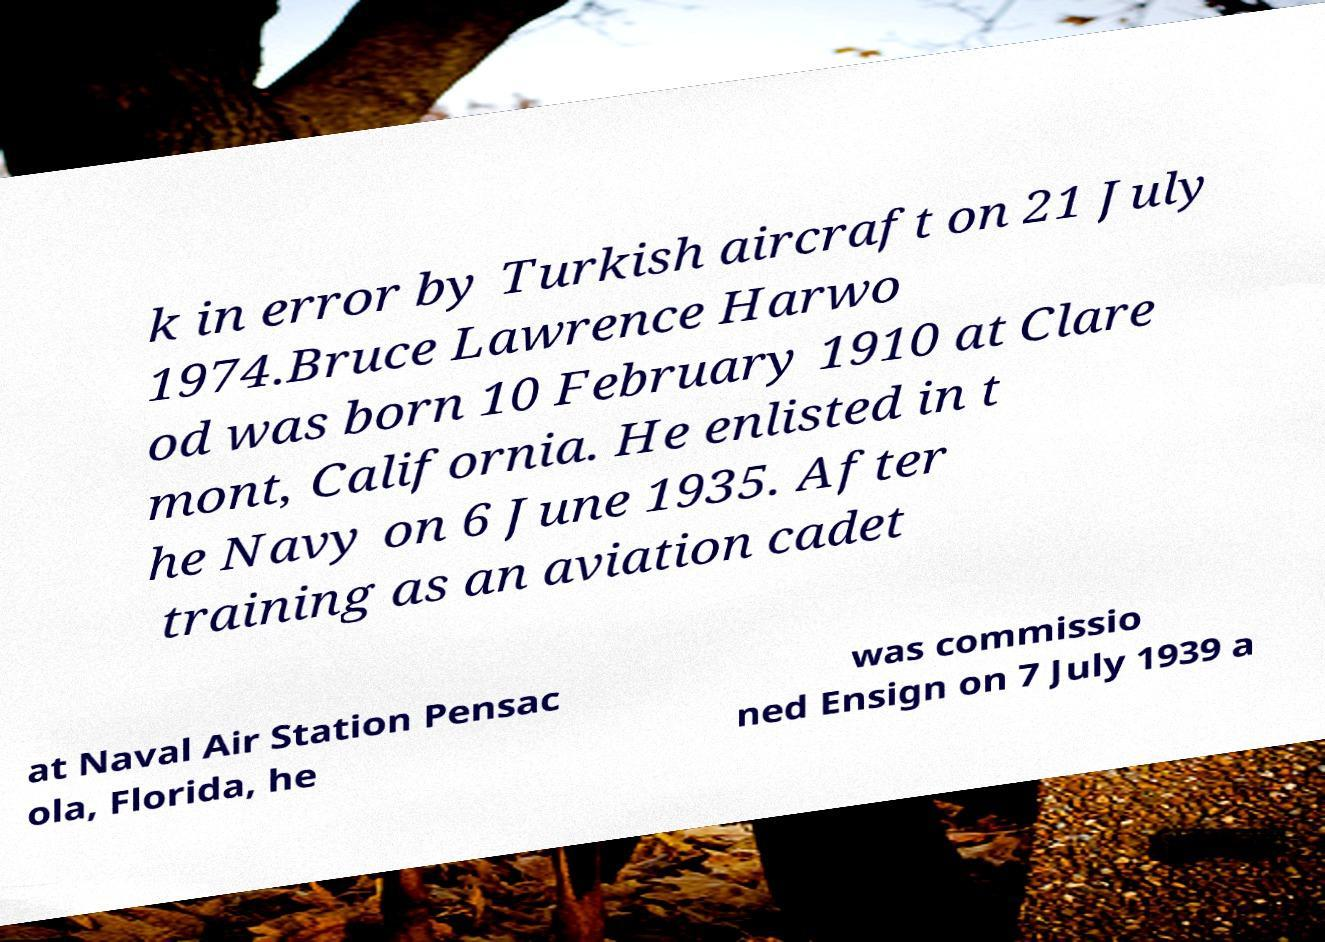There's text embedded in this image that I need extracted. Can you transcribe it verbatim? k in error by Turkish aircraft on 21 July 1974.Bruce Lawrence Harwo od was born 10 February 1910 at Clare mont, California. He enlisted in t he Navy on 6 June 1935. After training as an aviation cadet at Naval Air Station Pensac ola, Florida, he was commissio ned Ensign on 7 July 1939 a 